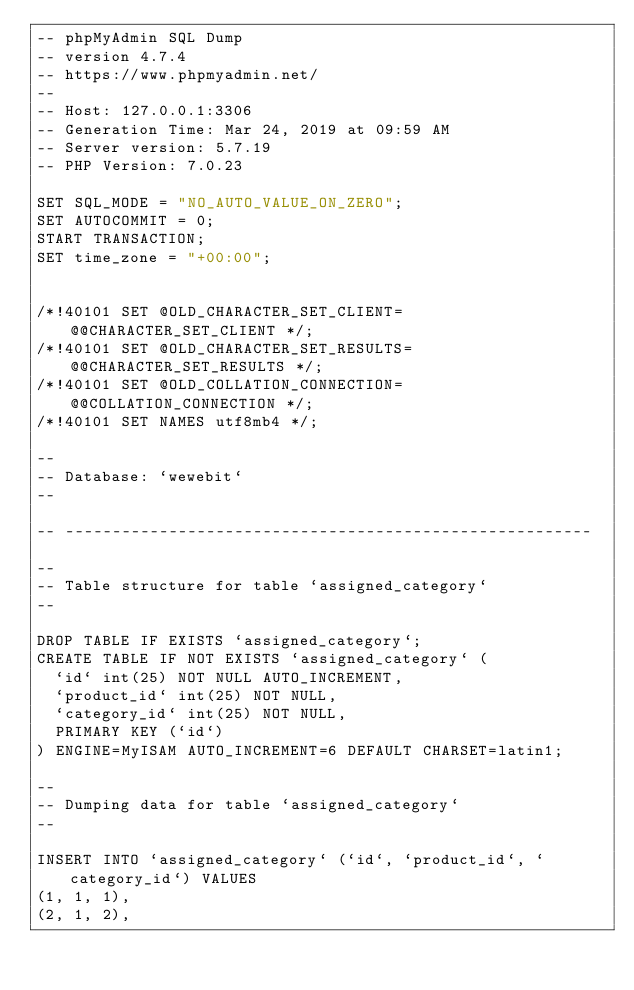Convert code to text. <code><loc_0><loc_0><loc_500><loc_500><_SQL_>-- phpMyAdmin SQL Dump
-- version 4.7.4
-- https://www.phpmyadmin.net/
--
-- Host: 127.0.0.1:3306
-- Generation Time: Mar 24, 2019 at 09:59 AM
-- Server version: 5.7.19
-- PHP Version: 7.0.23

SET SQL_MODE = "NO_AUTO_VALUE_ON_ZERO";
SET AUTOCOMMIT = 0;
START TRANSACTION;
SET time_zone = "+00:00";


/*!40101 SET @OLD_CHARACTER_SET_CLIENT=@@CHARACTER_SET_CLIENT */;
/*!40101 SET @OLD_CHARACTER_SET_RESULTS=@@CHARACTER_SET_RESULTS */;
/*!40101 SET @OLD_COLLATION_CONNECTION=@@COLLATION_CONNECTION */;
/*!40101 SET NAMES utf8mb4 */;

--
-- Database: `wewebit`
--

-- --------------------------------------------------------

--
-- Table structure for table `assigned_category`
--

DROP TABLE IF EXISTS `assigned_category`;
CREATE TABLE IF NOT EXISTS `assigned_category` (
  `id` int(25) NOT NULL AUTO_INCREMENT,
  `product_id` int(25) NOT NULL,
  `category_id` int(25) NOT NULL,
  PRIMARY KEY (`id`)
) ENGINE=MyISAM AUTO_INCREMENT=6 DEFAULT CHARSET=latin1;

--
-- Dumping data for table `assigned_category`
--

INSERT INTO `assigned_category` (`id`, `product_id`, `category_id`) VALUES
(1, 1, 1),
(2, 1, 2),</code> 